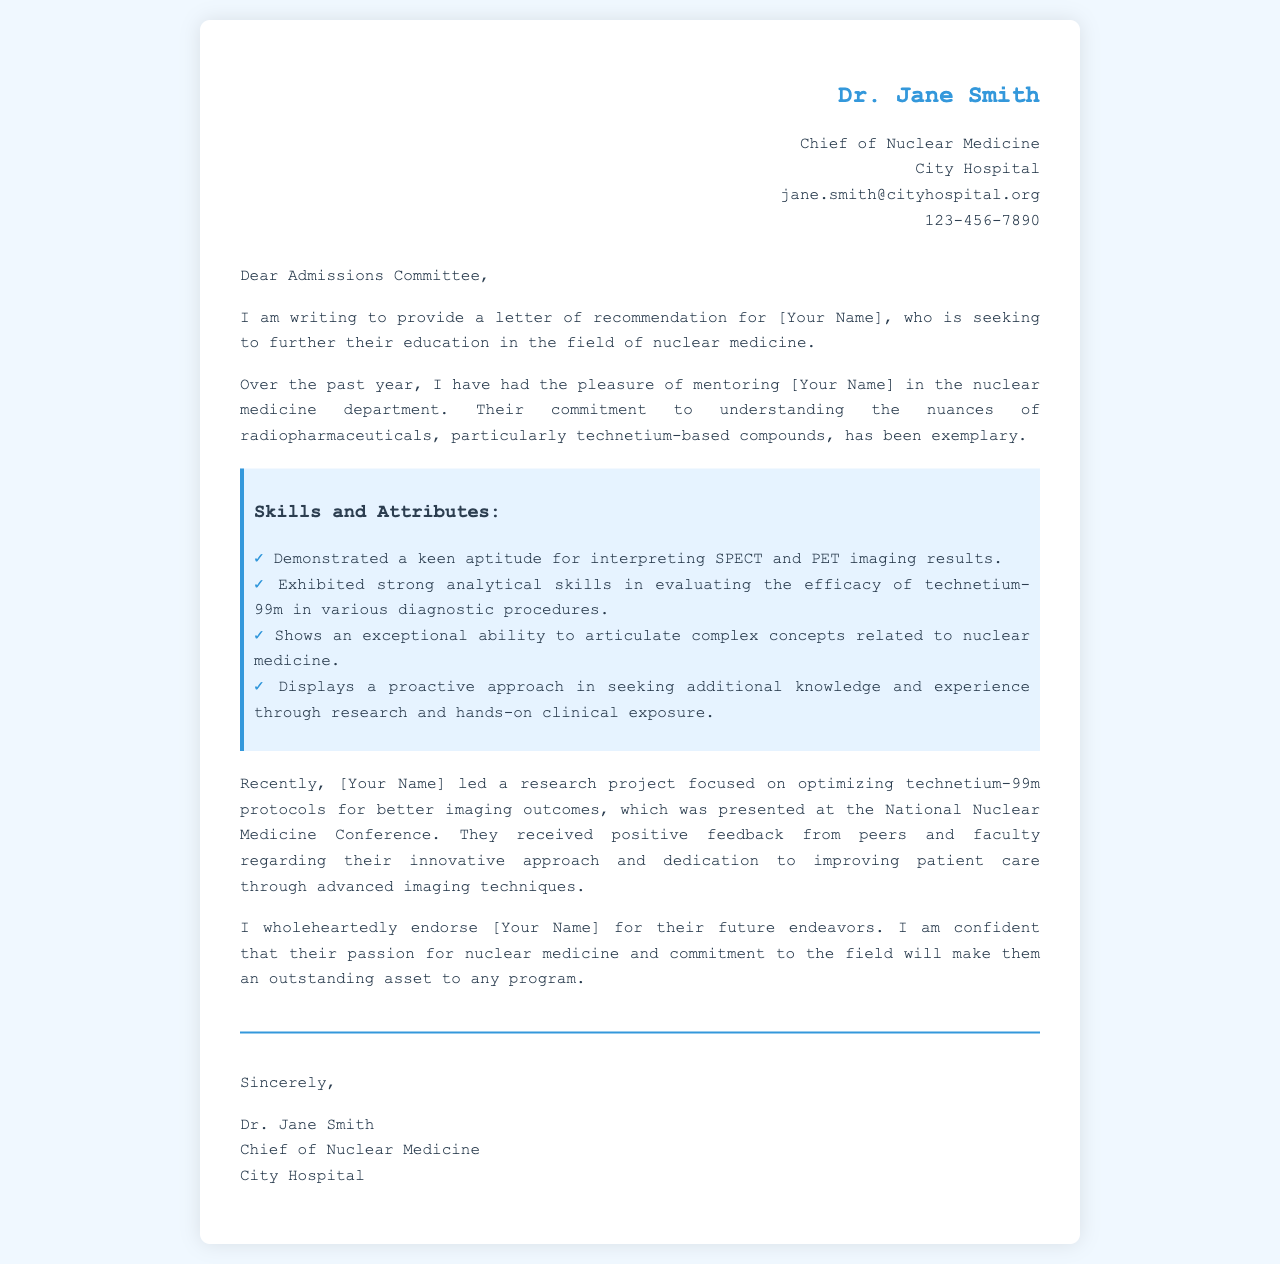What is the name of the recommender? The recommender's name is stated in the header of the letter.
Answer: Dr. Jane Smith What is the position of the recommender? The position of the recommender is listed immediately below their name.
Answer: Chief of Nuclear Medicine Which department did the mentor supervise? The department mentioned in the context of mentoring is specified in the letter.
Answer: Nuclear Medicine What is the focus of the research project led by [Your Name]? The focus of the research project is described in the document.
Answer: Optimizing technetium-99m protocols Where was the research presented? The location of the presentation is noted in the letter.
Answer: National Nuclear Medicine Conference What skill is highlighted regarding interpreting images? The skill related to image interpretation is mentioned in the skills and attributes section.
Answer: Interpreting SPECT and PET imaging results What compound's efficacy was evaluated? The document references a specific radiopharmaceutical compound evaluated by [Your Name].
Answer: Technetium-99m What type of letter is being described in this document? The nature of the document is implied by its content and purpose.
Answer: Letter of recommendation 